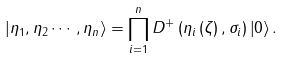<formula> <loc_0><loc_0><loc_500><loc_500>\left | \eta _ { 1 } , \eta _ { 2 } \cdots , \eta _ { n } \right \rangle = \prod _ { i = 1 } ^ { n } D ^ { + } \left ( \eta _ { i } \left ( \zeta \right ) , \sigma _ { i } \right ) \left | 0 \right \rangle .</formula> 